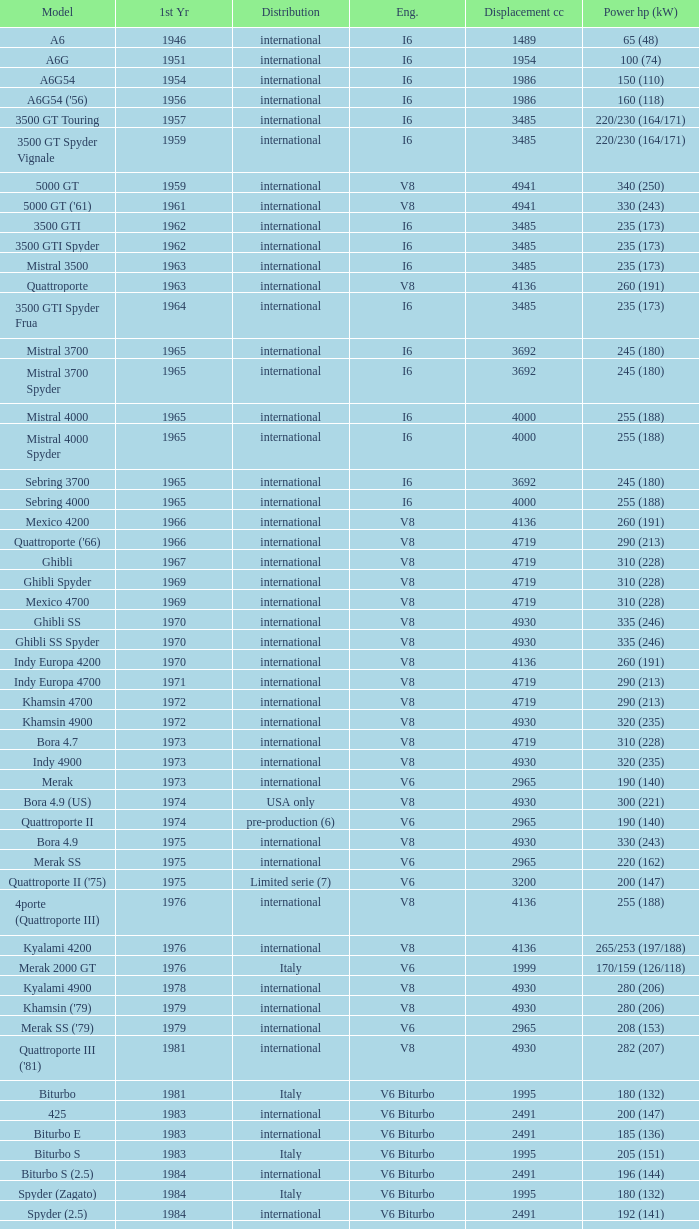What is the lowest First Year, when Model is "Quattroporte (2.8)"? 1994.0. 